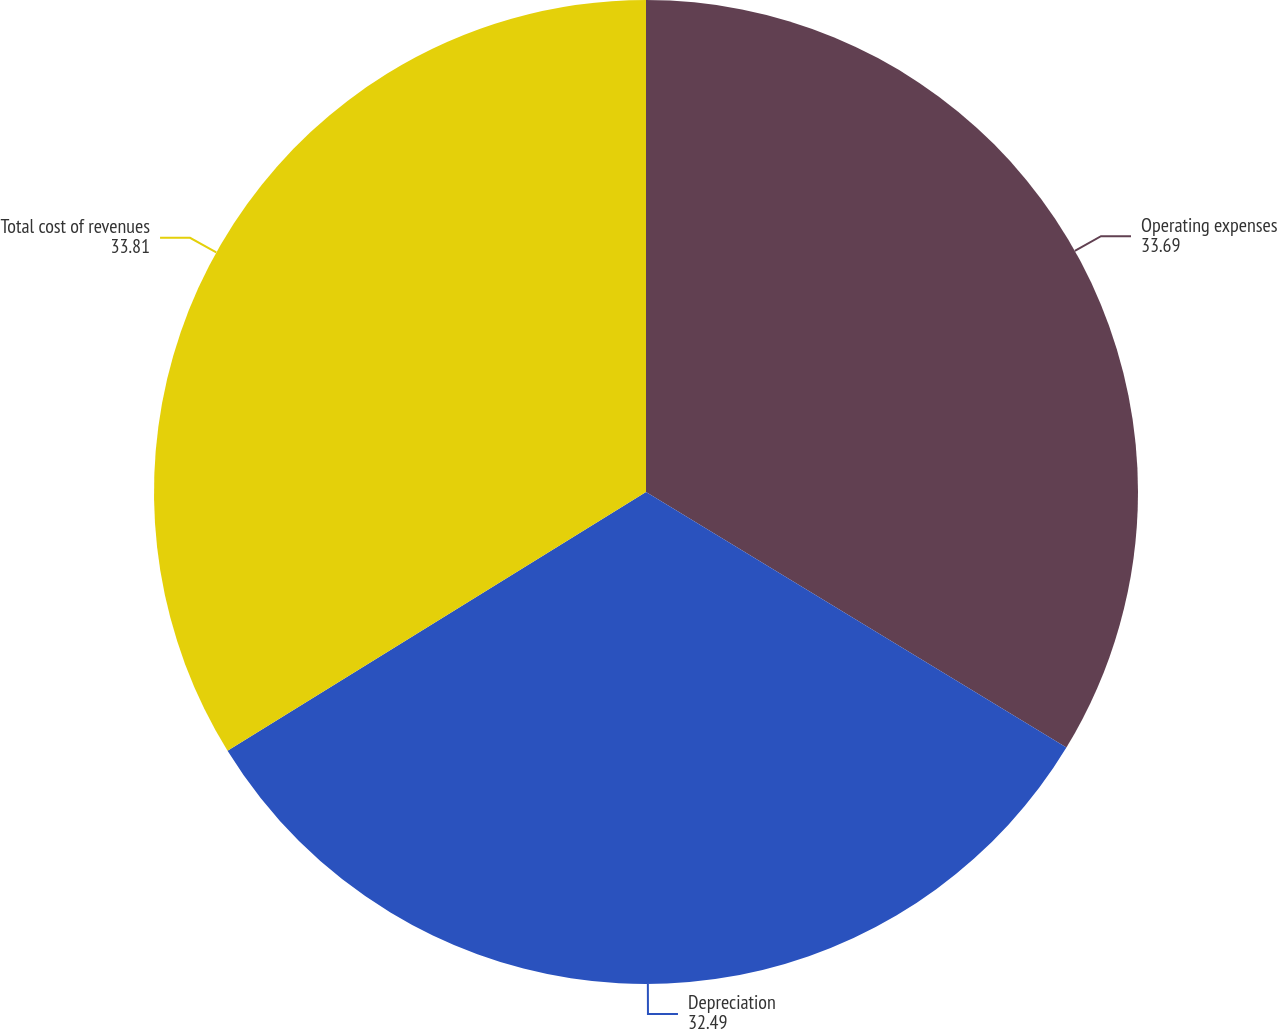<chart> <loc_0><loc_0><loc_500><loc_500><pie_chart><fcel>Operating expenses<fcel>Depreciation<fcel>Total cost of revenues<nl><fcel>33.69%<fcel>32.49%<fcel>33.81%<nl></chart> 